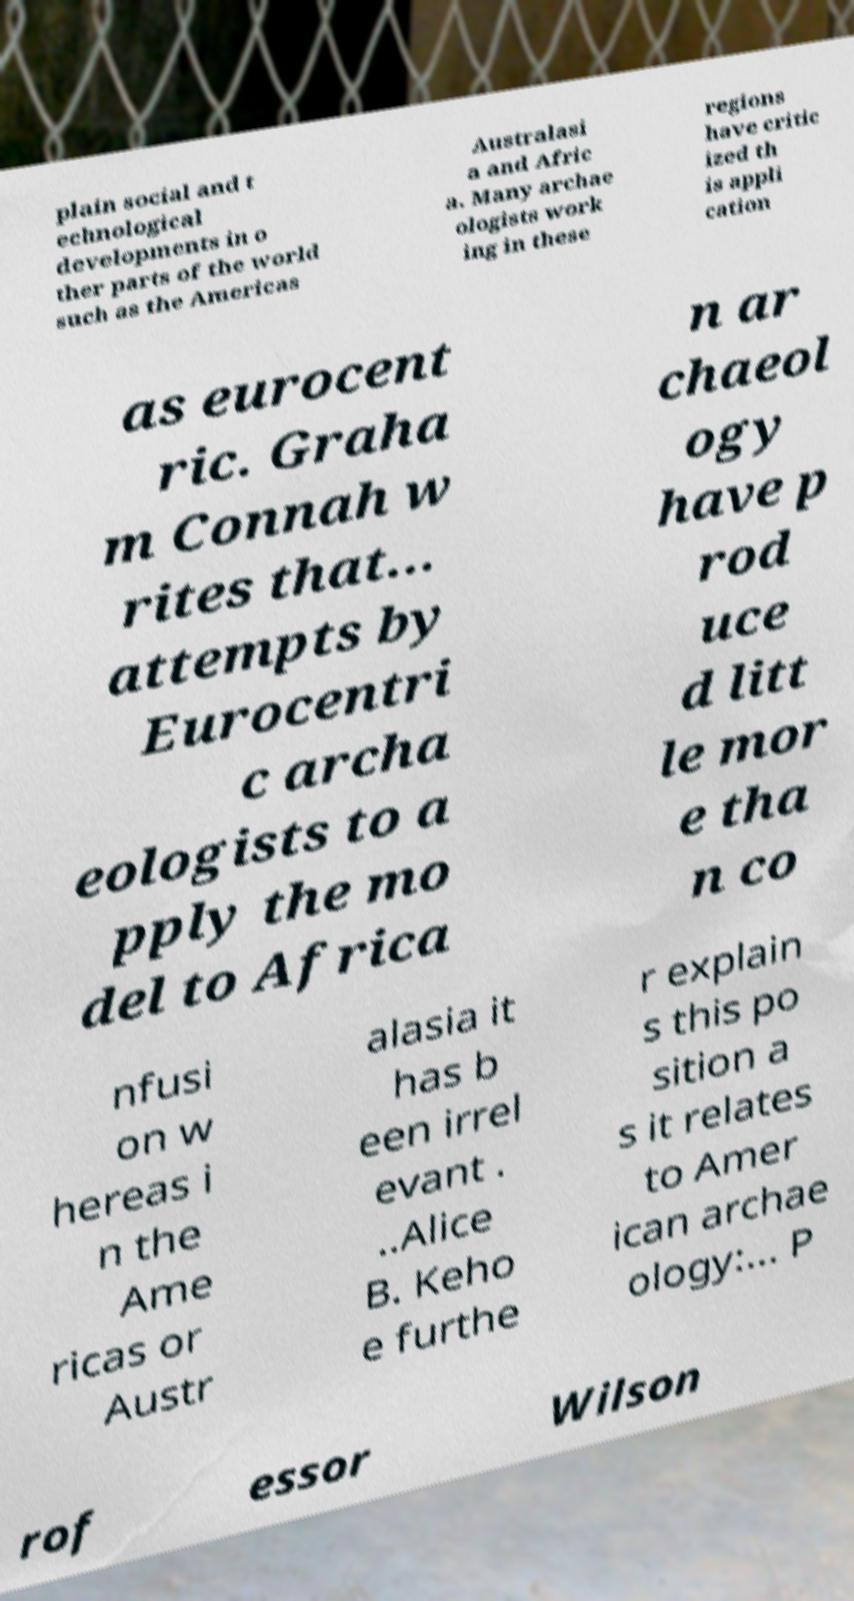Could you assist in decoding the text presented in this image and type it out clearly? plain social and t echnological developments in o ther parts of the world such as the Americas Australasi a and Afric a. Many archae ologists work ing in these regions have critic ized th is appli cation as eurocent ric. Graha m Connah w rites that... attempts by Eurocentri c archa eologists to a pply the mo del to Africa n ar chaeol ogy have p rod uce d litt le mor e tha n co nfusi on w hereas i n the Ame ricas or Austr alasia it has b een irrel evant . ..Alice B. Keho e furthe r explain s this po sition a s it relates to Amer ican archae ology:... P rof essor Wilson 